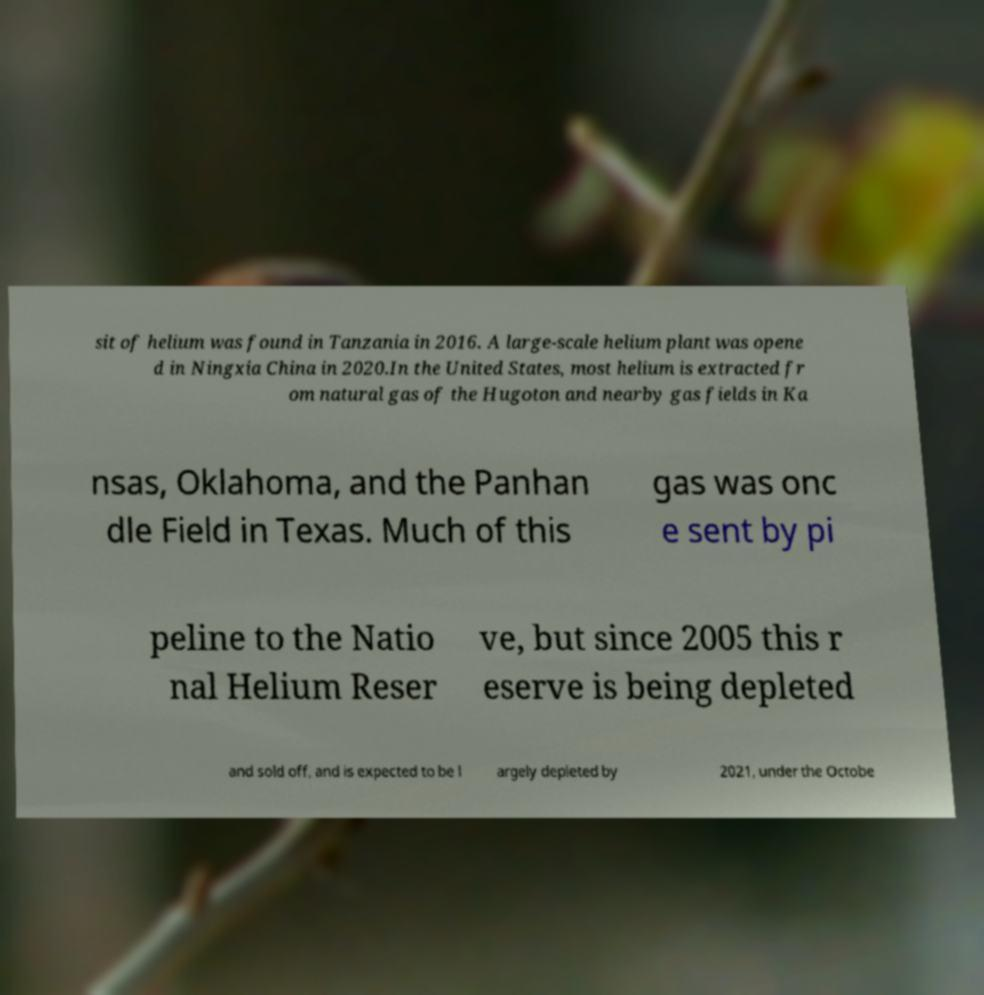Could you assist in decoding the text presented in this image and type it out clearly? sit of helium was found in Tanzania in 2016. A large-scale helium plant was opene d in Ningxia China in 2020.In the United States, most helium is extracted fr om natural gas of the Hugoton and nearby gas fields in Ka nsas, Oklahoma, and the Panhan dle Field in Texas. Much of this gas was onc e sent by pi peline to the Natio nal Helium Reser ve, but since 2005 this r eserve is being depleted and sold off, and is expected to be l argely depleted by 2021, under the Octobe 